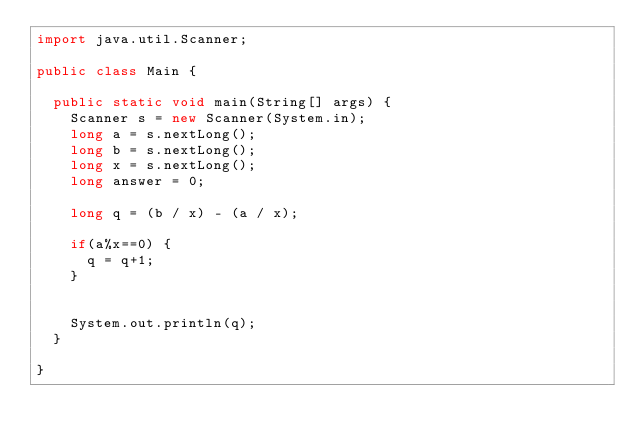<code> <loc_0><loc_0><loc_500><loc_500><_Java_>import java.util.Scanner;

public class Main {

	public static void main(String[] args) {
		Scanner s = new Scanner(System.in);
		long a = s.nextLong();
		long b = s.nextLong();
		long x = s.nextLong();
		long answer = 0;

		long q = (b / x) - (a / x);

		if(a%x==0) {
			q = q+1;
		}


		System.out.println(q);
	}

}</code> 